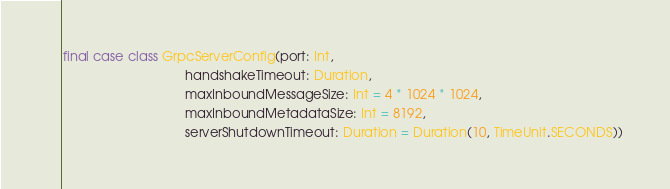Convert code to text. <code><loc_0><loc_0><loc_500><loc_500><_Scala_>
final case class GrpcServerConfig(port: Int,
                                  handshakeTimeout: Duration,
                                  maxInboundMessageSize: Int = 4 * 1024 * 1024,
                                  maxInboundMetadataSize: Int = 8192,
                                  serverShutdownTimeout: Duration = Duration(10, TimeUnit.SECONDS))
</code> 